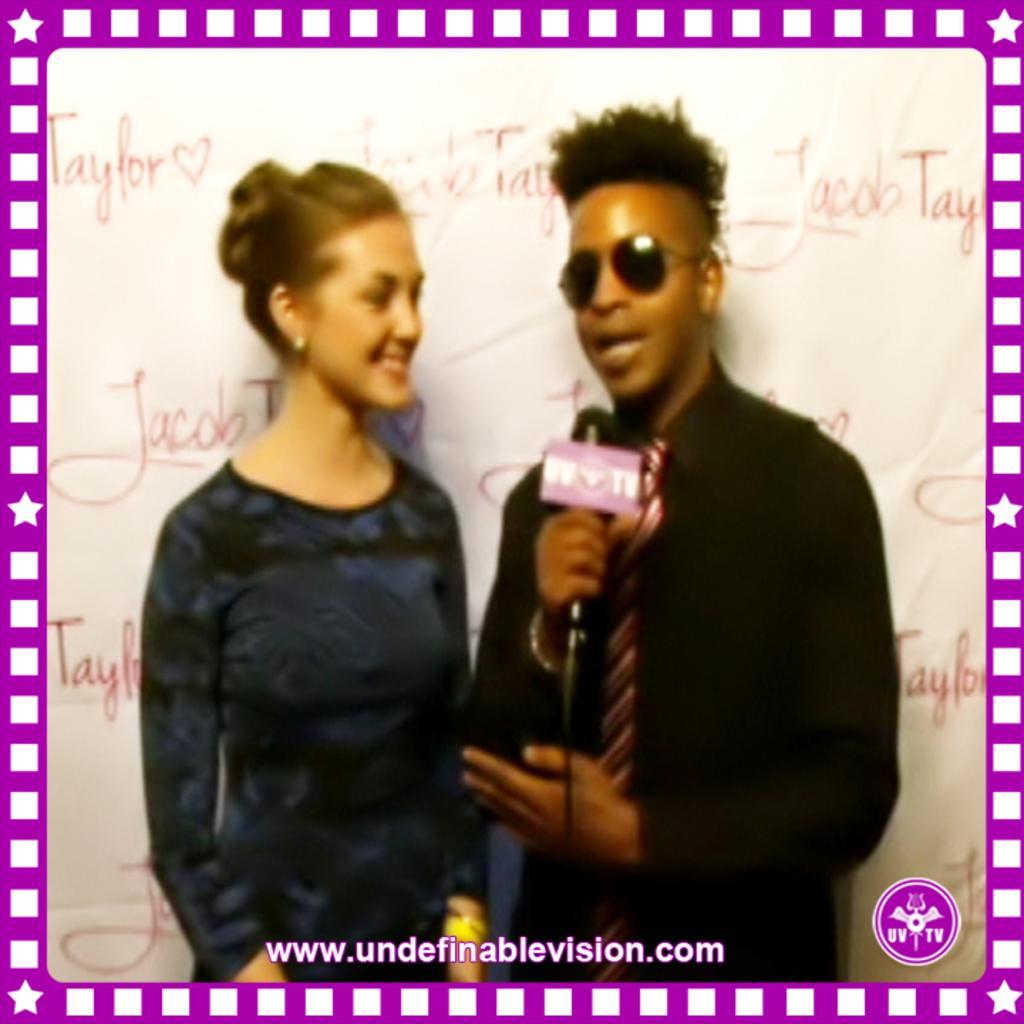Could you give a brief overview of what you see in this image? The man in black shirt is holding a microphone in his hand. He is talking on the microphone. Beside him, the woman in blue dress is stunning. She is smiling. He might be interviewing her. Behind them, we see a white banner with some text written on it. This is an edited image. 